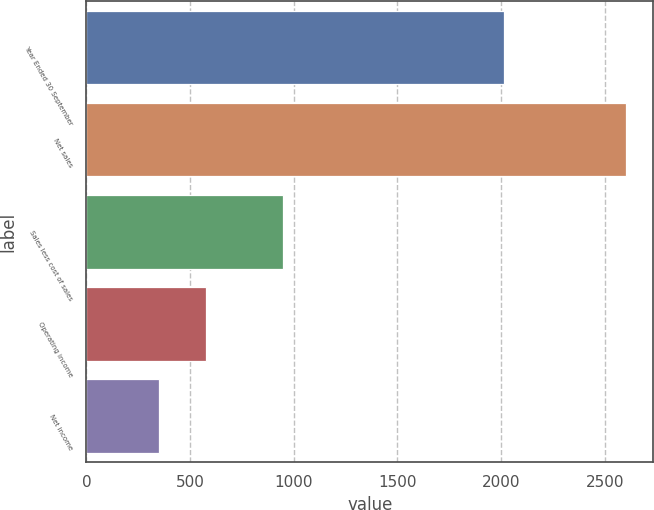<chart> <loc_0><loc_0><loc_500><loc_500><bar_chart><fcel>Year Ended 30 September<fcel>Net sales<fcel>Sales less cost of sales<fcel>Operating income<fcel>Net income<nl><fcel>2015<fcel>2604.3<fcel>949.2<fcel>576.33<fcel>351<nl></chart> 